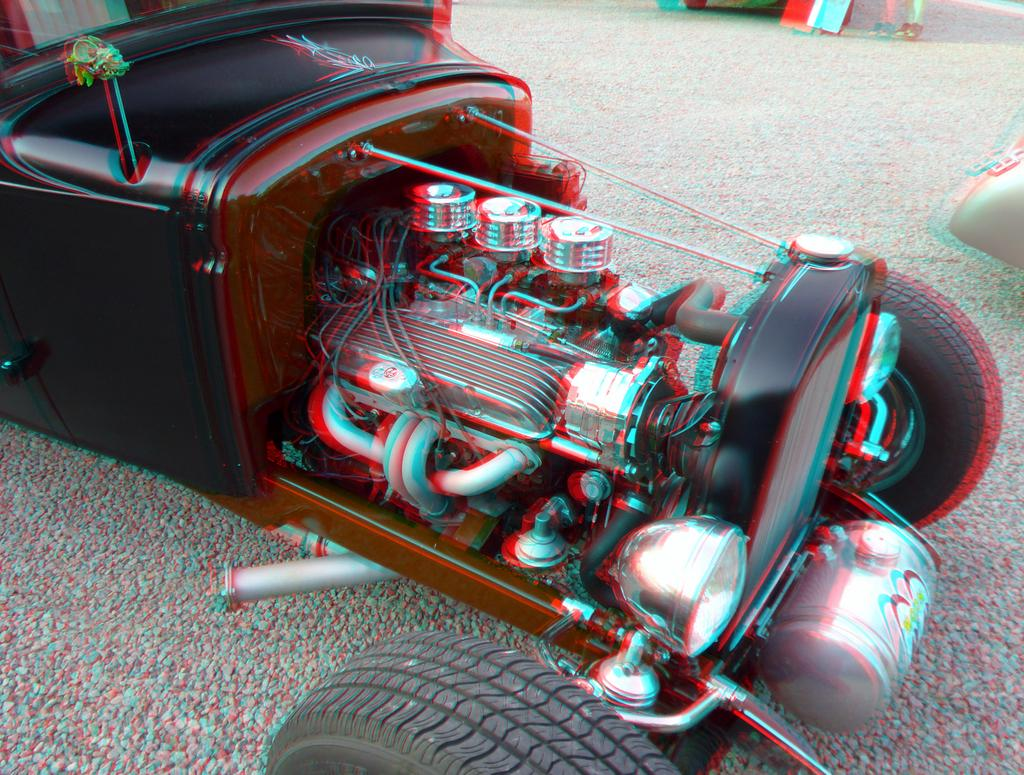What is the main subject in the image? There is a vehicle in the image. Can you describe the position of the vehicle? The vehicle is on the ground. What can be seen in the background of the image? There are objects visible in the background of the image. What type of waste can be seen on the edge of the sidewalk in the image? There is no sidewalk or waste present in the image; it features a vehicle on the ground with objects visible in the background. 